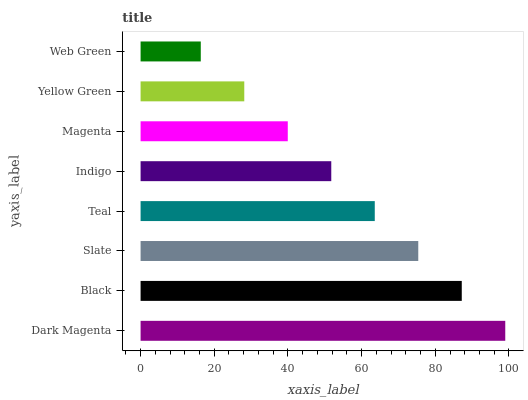Is Web Green the minimum?
Answer yes or no. Yes. Is Dark Magenta the maximum?
Answer yes or no. Yes. Is Black the minimum?
Answer yes or no. No. Is Black the maximum?
Answer yes or no. No. Is Dark Magenta greater than Black?
Answer yes or no. Yes. Is Black less than Dark Magenta?
Answer yes or no. Yes. Is Black greater than Dark Magenta?
Answer yes or no. No. Is Dark Magenta less than Black?
Answer yes or no. No. Is Teal the high median?
Answer yes or no. Yes. Is Indigo the low median?
Answer yes or no. Yes. Is Magenta the high median?
Answer yes or no. No. Is Magenta the low median?
Answer yes or no. No. 